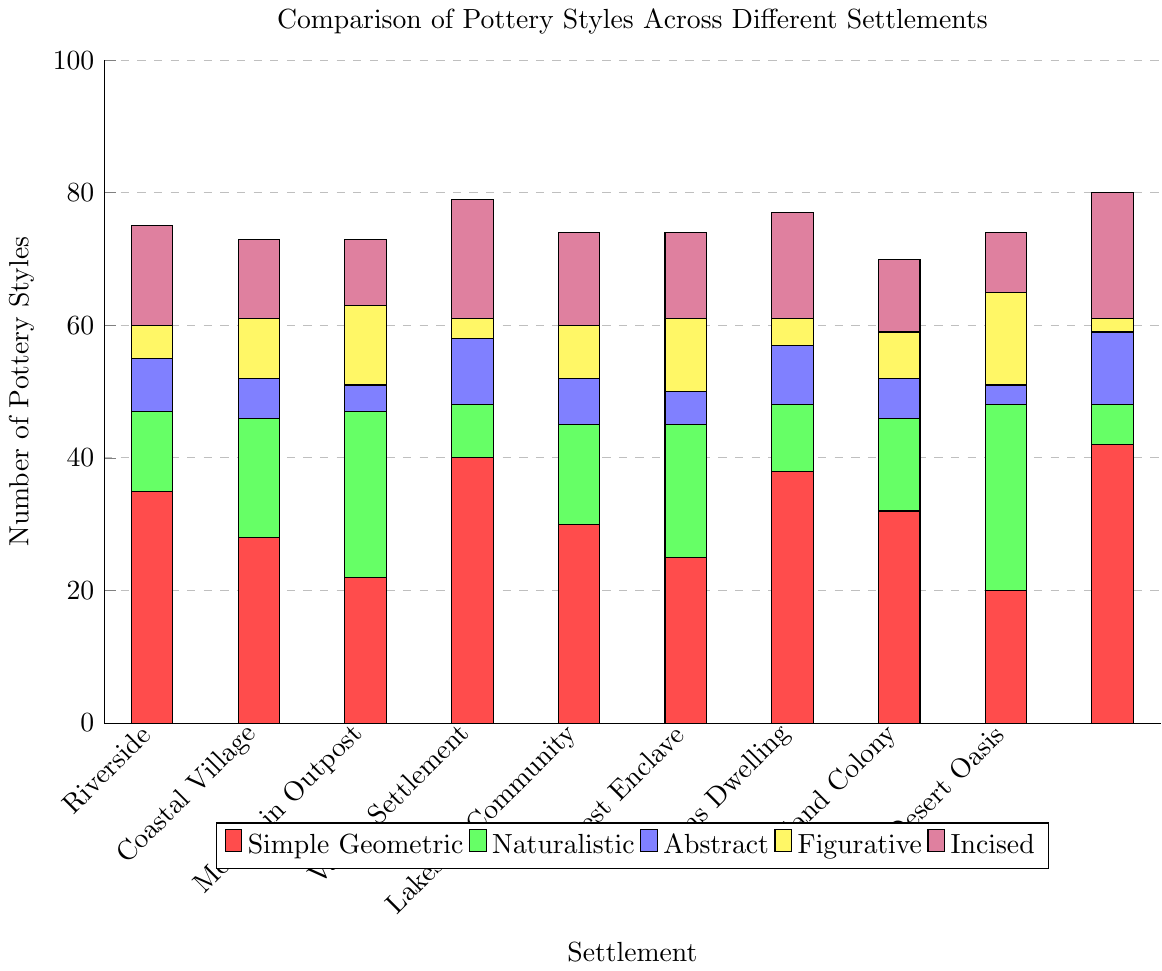What's the settlement with the highest count of Simple Geometric pottery? The red bars represent Simple Geometric pottery. By visually comparing the heights of the red bars, Desert Oasis has the highest count for Simple Geometric with a value of 42.
Answer: Desert Oasis Which two settlements have the same amount of Figurative pottery? Figurative pottery is shown by yellow bars. From the visual comparison, Plains Dwelling and Valley Settlement both have 7 pieces of Figurative pottery.
Answer: Plains Dwelling and Valley Settlement How many more Simple Geometric pottery styles does Forest Enclave have compared to Coastal Village? Forest Enclave has 38 pieces (the red bar) of Simple Geometric pottery, and Coastal Village has 22. Subtracting these two gives us 38 - 22 = 16.
Answer: 16 Which settlement has the lowest count of Naturalistic pottery, and what is the count? Naturalistic pottery is represented by green bars. The smallest green bar is for Desert Oasis with a count of 6.
Answer: Desert Oasis, 6 What is the total number of Abstract pottery pieces in Mountain Outpost? Abstract pottery is represented by blue bars. In Mountain Outpost, the count is 10 pieces of Abstract pottery.
Answer: 10 Which settlement has a higher total count of Abstract and Figurative pottery combined, Lakeside Community or Island Colony? Lakeside Community has 5 pieces (blue) + 11 pieces (yellow) = 16, while Island Colony has 3 pieces (blue) + 14 pieces (yellow) = 17. Therefore, Island Colony has more Abstract and Figurative pottery combined.
Answer: Island Colony Which pottery style is the most common across all settlements? By visually comparing the highest cumulative heights of each color bar, Simple Geometric (red bars) appears to be dominant in most settlements.
Answer: Simple Geometric What is the difference between the number of Incised pottery styles in Riverside and Mountain Outpost? Riverside has 12 pieces of Incised pottery (purple), while Mountain Outpost has 18 pieces. The difference is 18 - 12 = 6.
Answer: 6 Across all settlements, what is the range of the number of Figurative pottery styles? The lowest count is 2 (Desert Oasis) and the highest is 14 (Island Colony). The range is 14 - 2 = 12.
Answer: 12 